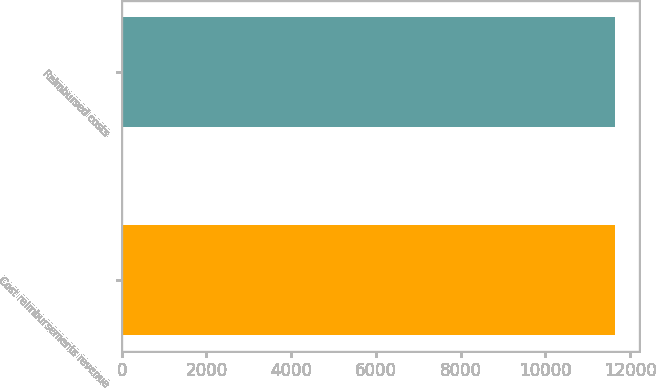Convert chart to OTSL. <chart><loc_0><loc_0><loc_500><loc_500><bar_chart><fcel>Cost reimbursements revenue<fcel>Reimbursed costs<nl><fcel>11630<fcel>11630.1<nl></chart> 